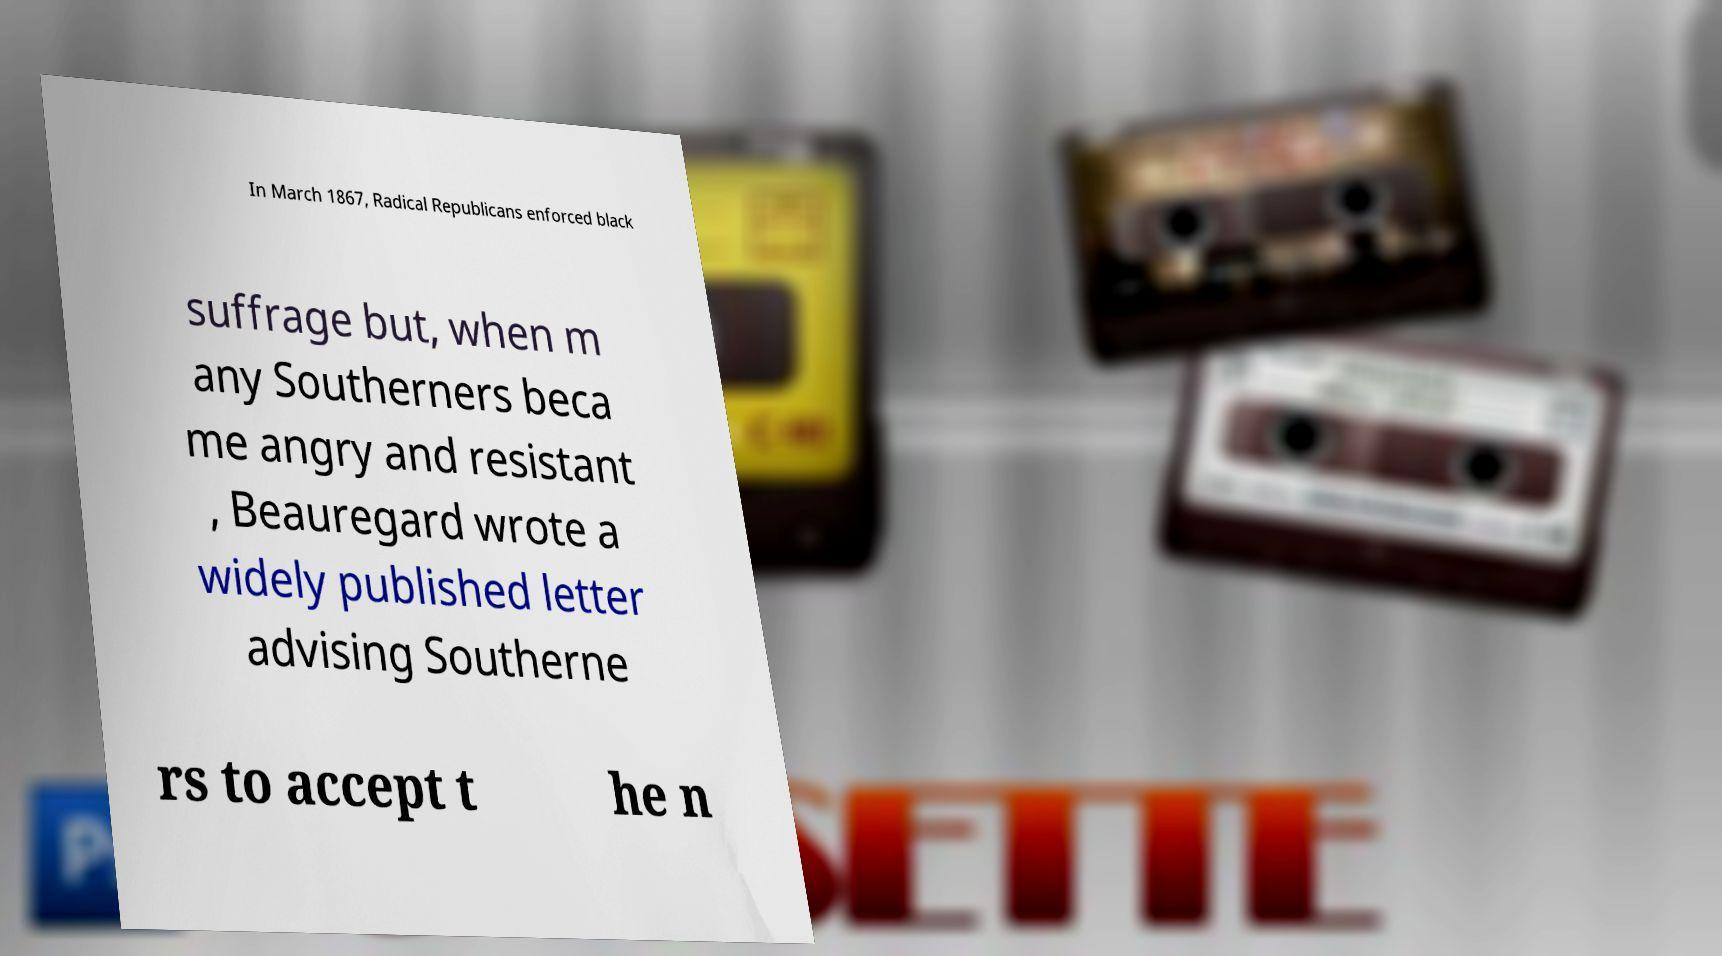Could you extract and type out the text from this image? In March 1867, Radical Republicans enforced black suffrage but, when m any Southerners beca me angry and resistant , Beauregard wrote a widely published letter advising Southerne rs to accept t he n 